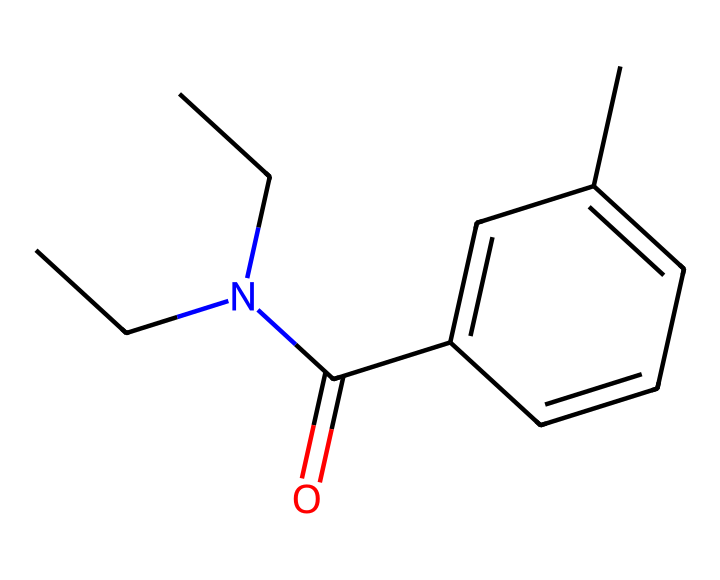What is the name of this chemical? The chemical structure corresponds to the name N,N-diethyl-meta-toluamide, known commonly as DEET. The name can be derived from the structure, which showcases the diethyl groups and a toluamide functional group.
Answer: N,N-diethyl-meta-toluamide How many carbon atoms are in the structure? Counting the carbon atoms in the structure, we identify three in the diethyl group, six in the toluene part, and one from the carbonyl, leading to a total of ten carbon atoms.
Answer: ten What functional group is present in this structure? The structural representation indicates the presence of an amide functional group (-C(=O)N-), which is a defining characteristic of this chemical. This is seen from the carbonyl attached to the nitrogen.
Answer: amide Is this chemical polar or nonpolar? Considering the presence of the carbonyl group and the nitrogen, this chemical has both polar and nonpolar characteristics, but overall, it leans towards being nonpolar due to the long carbon chains.
Answer: nonpolar What is the main purpose of this compound? N,N-diethyl-meta-toluamide is primarily used as an insect repellent, which is evident from its structure designed to deter pests effectively.
Answer: insect repellent Which element in the structure indicates that it can form hydrogen bonds? The presence of nitrogen in the amide functional group suggests that this compound can engage in hydrogen bonding due to its lone pair electrons and possible donor capacity.
Answer: nitrogen Does this compound belong to the category of imides? Though the compound contains the amide functional group, it does not classify as an imide, which specifically requires two acyl groups attached to the same nitrogen atom.
Answer: no 